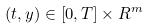<formula> <loc_0><loc_0><loc_500><loc_500>( t , y ) \in [ 0 , T ] \times R ^ { m }</formula> 